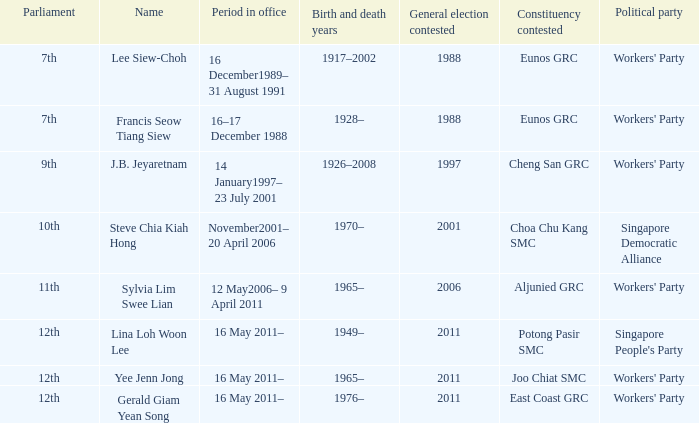In which parliament does lina loh woon lee hold membership? 12th. 